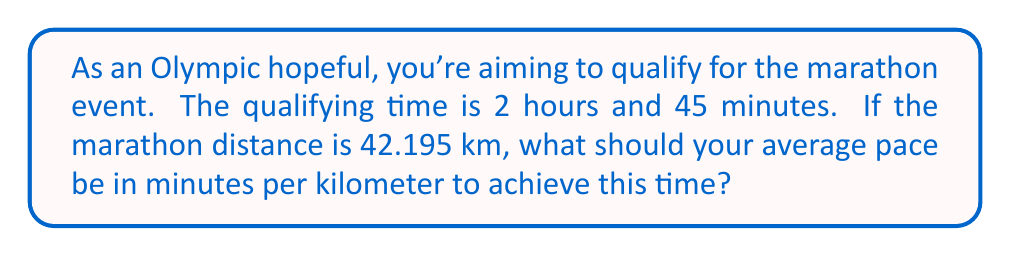Show me your answer to this math problem. Let's approach this step-by-step:

1) First, convert the time to minutes:
   2 hours and 45 minutes = (2 × 60) + 45 = 165 minutes

2) Now, we need to find the pace in minutes per kilometer. We can use the formula:
   $$ \text{Pace} = \frac{\text{Total Time}}{\text{Distance}} $$

3) Substituting our values:
   $$ \text{Pace} = \frac{165 \text{ minutes}}{42.195 \text{ km}} $$

4) Perform the division:
   $$ \text{Pace} = 3.91087... \text{ minutes/km} $$

5) Since we're dealing with time, let's convert this to minutes and seconds:
   0.91087 minutes = 0.91087 × 60 seconds = 54.6522 seconds ≈ 55 seconds

Therefore, the required pace is 3 minutes and 55 seconds per kilometer.
Answer: 3:55 min/km 